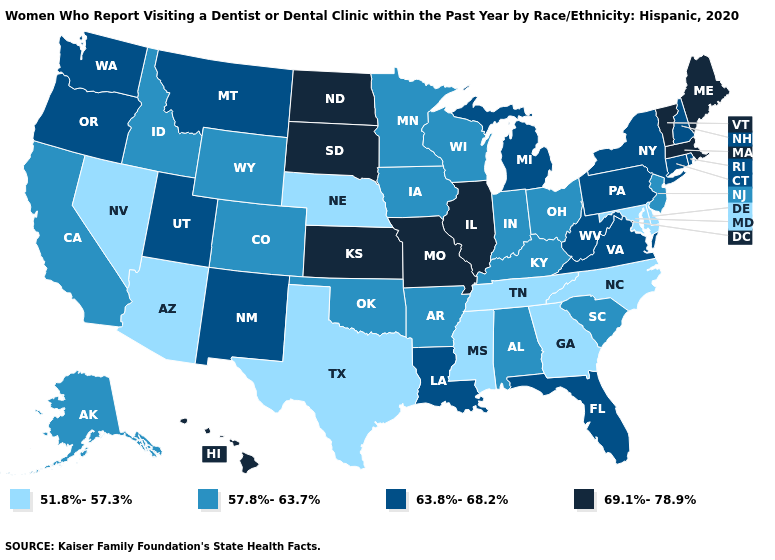How many symbols are there in the legend?
Short answer required. 4. Does Minnesota have a lower value than Louisiana?
Keep it brief. Yes. What is the value of Kentucky?
Answer briefly. 57.8%-63.7%. Does Oregon have the highest value in the USA?
Be succinct. No. Which states have the lowest value in the West?
Concise answer only. Arizona, Nevada. What is the value of North Carolina?
Keep it brief. 51.8%-57.3%. Does New Hampshire have the highest value in the Northeast?
Concise answer only. No. Name the states that have a value in the range 57.8%-63.7%?
Answer briefly. Alabama, Alaska, Arkansas, California, Colorado, Idaho, Indiana, Iowa, Kentucky, Minnesota, New Jersey, Ohio, Oklahoma, South Carolina, Wisconsin, Wyoming. What is the value of Iowa?
Short answer required. 57.8%-63.7%. Which states have the lowest value in the USA?
Give a very brief answer. Arizona, Delaware, Georgia, Maryland, Mississippi, Nebraska, Nevada, North Carolina, Tennessee, Texas. Which states have the lowest value in the Northeast?
Keep it brief. New Jersey. What is the highest value in states that border Connecticut?
Write a very short answer. 69.1%-78.9%. Does Mississippi have the highest value in the USA?
Short answer required. No. Name the states that have a value in the range 51.8%-57.3%?
Be succinct. Arizona, Delaware, Georgia, Maryland, Mississippi, Nebraska, Nevada, North Carolina, Tennessee, Texas. 